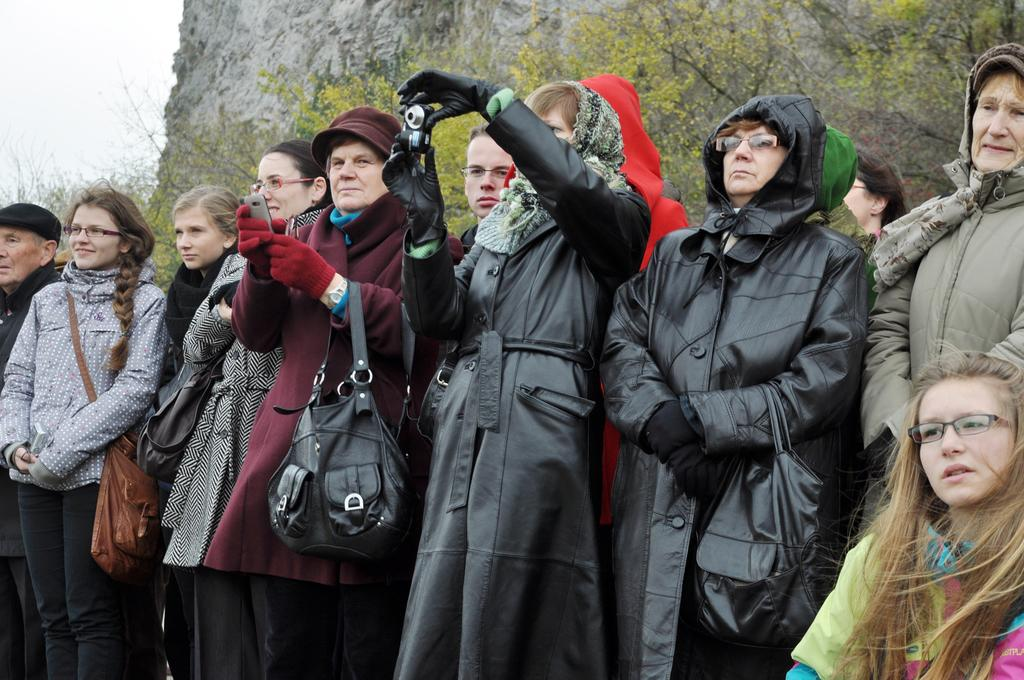What is happening in the image? There are people standing in the image. What can be seen in the background of the image? There are green color plants and trees, as well as a mountain visible in the background of the image. Where is the toothbrush located in the image? There is no toothbrush present in the image. What type of stretch can be seen in the image? There is no stretch visible in the image; it features people standing and a mountainous background. 